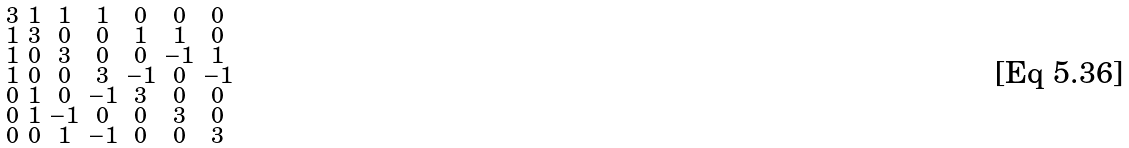<formula> <loc_0><loc_0><loc_500><loc_500>\begin{smallmatrix} 3 & 1 & 1 & 1 & 0 & 0 & 0 \\ 1 & 3 & 0 & 0 & 1 & 1 & 0 \\ 1 & 0 & 3 & 0 & 0 & - 1 & 1 \\ 1 & 0 & 0 & 3 & - 1 & 0 & - 1 \\ 0 & 1 & 0 & - 1 & 3 & 0 & 0 \\ 0 & 1 & - 1 & 0 & 0 & 3 & 0 \\ 0 & 0 & 1 & - 1 & 0 & 0 & 3 \end{smallmatrix}</formula> 